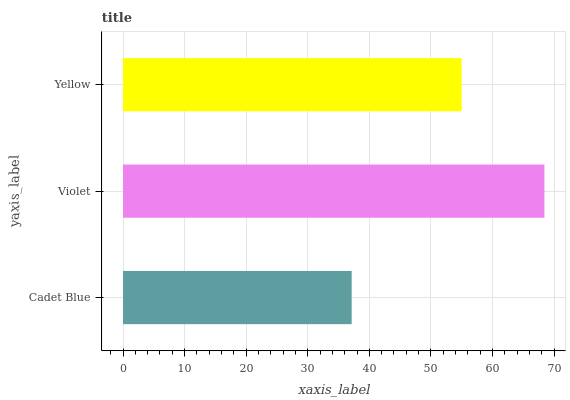Is Cadet Blue the minimum?
Answer yes or no. Yes. Is Violet the maximum?
Answer yes or no. Yes. Is Yellow the minimum?
Answer yes or no. No. Is Yellow the maximum?
Answer yes or no. No. Is Violet greater than Yellow?
Answer yes or no. Yes. Is Yellow less than Violet?
Answer yes or no. Yes. Is Yellow greater than Violet?
Answer yes or no. No. Is Violet less than Yellow?
Answer yes or no. No. Is Yellow the high median?
Answer yes or no. Yes. Is Yellow the low median?
Answer yes or no. Yes. Is Violet the high median?
Answer yes or no. No. Is Violet the low median?
Answer yes or no. No. 